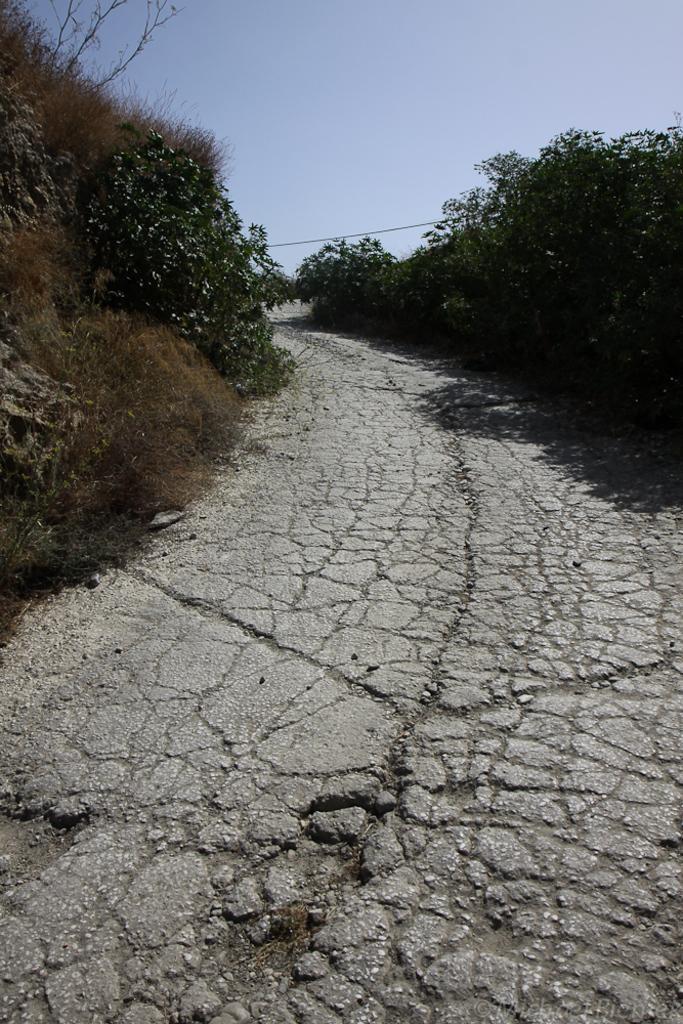How would you summarize this image in a sentence or two? In this image I can see a pathway. I can also see trees in green color and the sky is in blue color. 